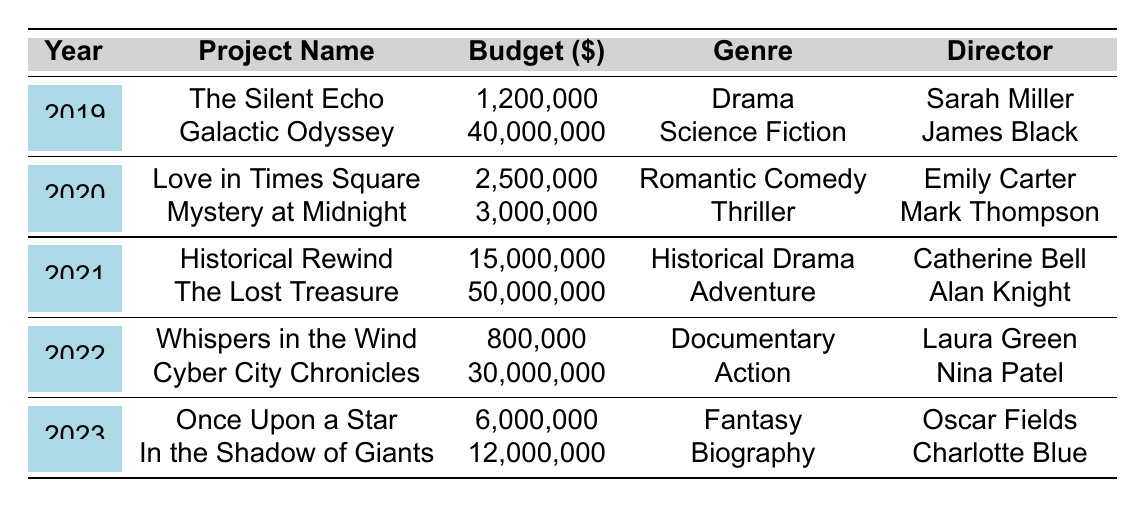What is the budget of "Galactic Odyssey"? The budget for "Galactic Odyssey", as shown in the table, is listed directly next to the project name under the corresponding year. It reads 40,000,000.
Answer: 40,000,000 Which genre had the highest budget in 2021? In 2021, the table lists "The Lost Treasure" with a budget of 50,000,000 as an Adventure film, which is the highest budget for that year. "Historical Rewind" has a lower budget at 15,000,000 and falls under Historical Drama.
Answer: Adventure What is the total budget for film projects in 2022? The total budget for 2022 is calculated by adding the budgets of both projects in that year: 800,000 (Whispers in the Wind) + 30,000,000 (Cyber City Chronicles) = 30,800,000.
Answer: 30,800,000 How many film projects were released in 2023? The table indicates that there are two film projects for the year 2023: "Once Upon a Star" and "In the Shadow of Giants."
Answer: 2 Is there any film project directed by Charlotte Blue? Yes, according to the table, "In the Shadow of Giants" is directed by Charlotte Blue.
Answer: Yes What was the average budget of all film projects in 2019? The total budget for 2019 is 1,200,000 (The Silent Echo) + 40,000,000 (Galactic Odyssey) = 41,200,000. There are 2 projects, so the average is 41,200,000 / 2 = 20,600,000.
Answer: 20,600,000 Which director has the lowest budget film in 2022? In 2022, "Whispers in the Wind," directed by Laura Green, has the lowest budget at 800,000 compared to "Cyber City Chronicles," which has a budget of 30,000,000.
Answer: Laura Green What genre is "The Lost Treasure"? The genre listed for "The Lost Treasure" in the table is Adventure.
Answer: Adventure How much higher is the budget of "Cyber City Chronicles" compared to "Whispers in the Wind"? To find how much higher, subtract the budget of "Whispers in the Wind" (800,000) from that of "Cyber City Chronicles" (30,000,000): 30,000,000 - 800,000 = 29,200,000.
Answer: 29,200,000 What year had the highest total budget across all projects? Calculate total budgets for each year. 2019: 41,200,000; 2020: 5,500,000; 2021: 65,000,000; 2022: 30,800,000; 2023: 18,000,000. Year 2021 has the highest total budget at 65,000,000.
Answer: 2021 